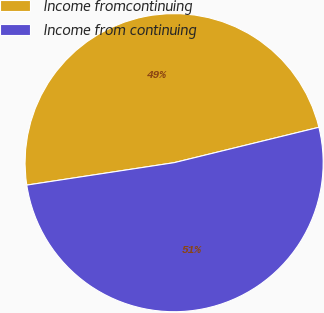Convert chart. <chart><loc_0><loc_0><loc_500><loc_500><pie_chart><fcel>Income fromcontinuing<fcel>Income from continuing<nl><fcel>48.59%<fcel>51.41%<nl></chart> 